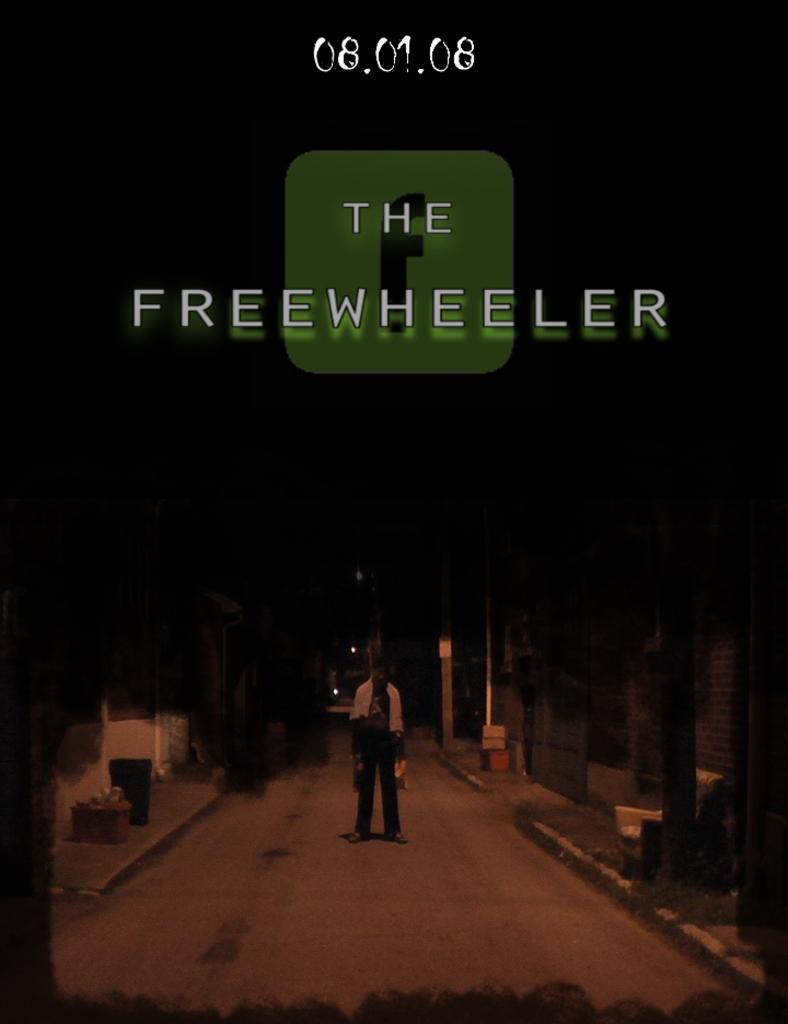Provide a one-sentence caption for the provided image. A poster for The Freewheeler available on 08.01.08. 